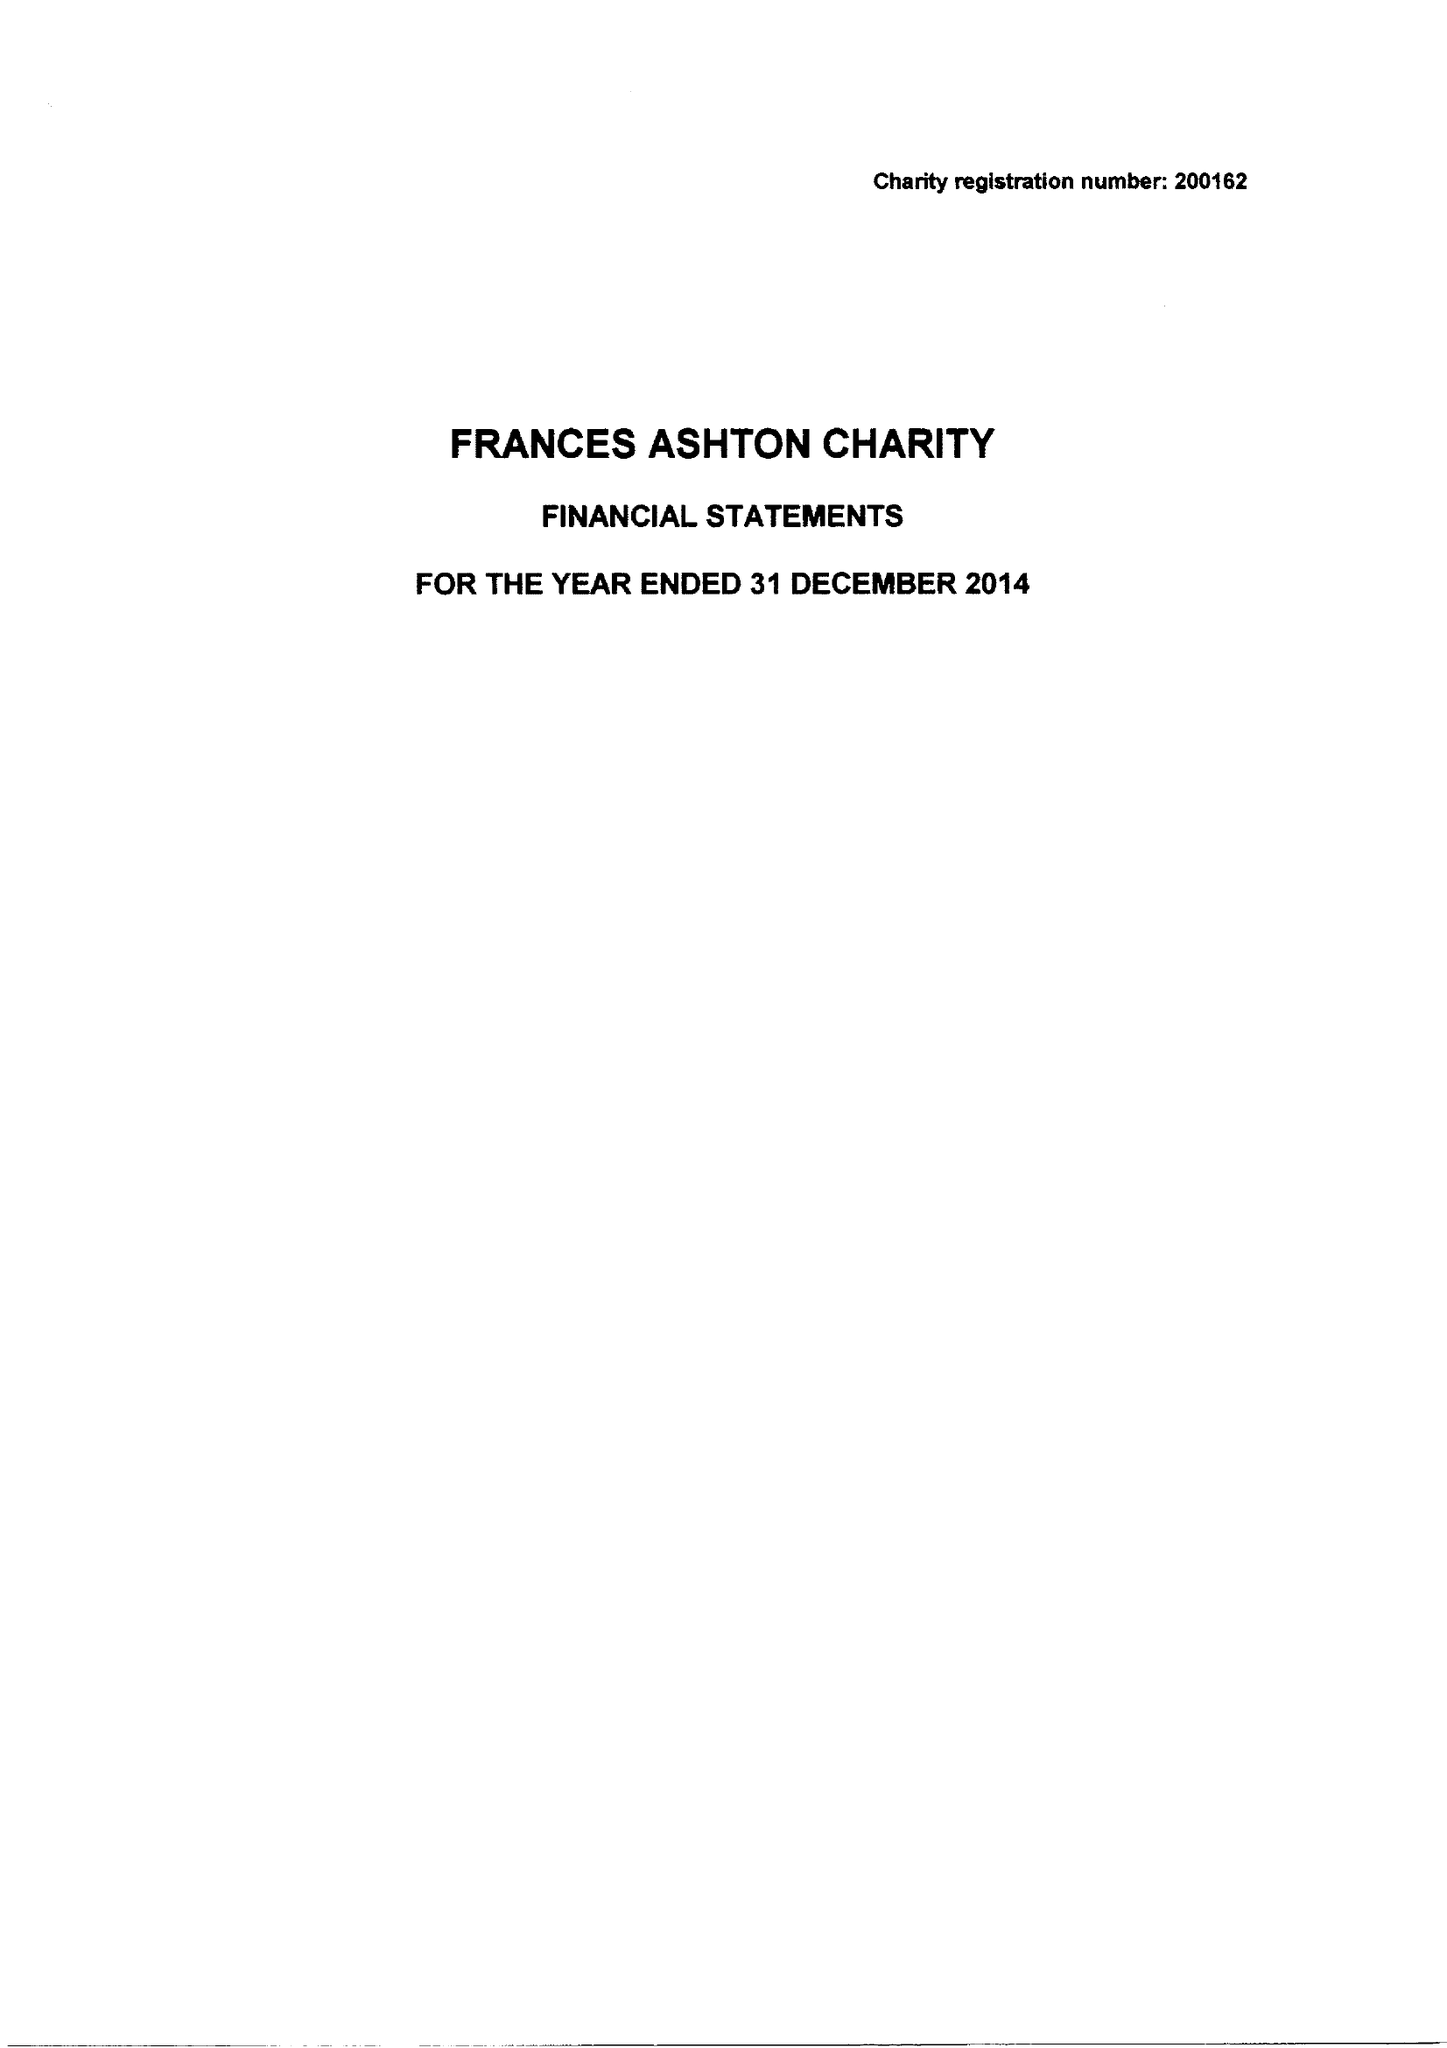What is the value for the address__street_line?
Answer the question using a single word or phrase. GRACIOUS STREET 